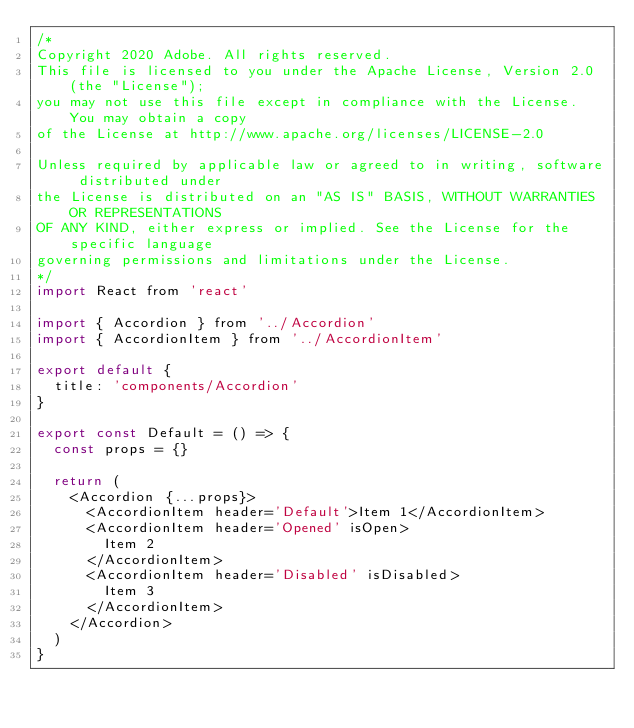Convert code to text. <code><loc_0><loc_0><loc_500><loc_500><_JavaScript_>/*
Copyright 2020 Adobe. All rights reserved.
This file is licensed to you under the Apache License, Version 2.0 (the "License");
you may not use this file except in compliance with the License. You may obtain a copy
of the License at http://www.apache.org/licenses/LICENSE-2.0

Unless required by applicable law or agreed to in writing, software distributed under
the License is distributed on an "AS IS" BASIS, WITHOUT WARRANTIES OR REPRESENTATIONS
OF ANY KIND, either express or implied. See the License for the specific language
governing permissions and limitations under the License.
*/
import React from 'react'

import { Accordion } from '../Accordion'
import { AccordionItem } from '../AccordionItem'

export default {
  title: 'components/Accordion'
}

export const Default = () => {
  const props = {}

  return (
    <Accordion {...props}>
      <AccordionItem header='Default'>Item 1</AccordionItem>
      <AccordionItem header='Opened' isOpen>
        Item 2
      </AccordionItem>
      <AccordionItem header='Disabled' isDisabled>
        Item 3
      </AccordionItem>
    </Accordion>
  )
}
</code> 